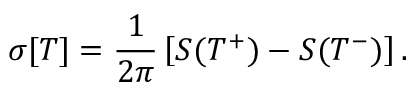<formula> <loc_0><loc_0><loc_500><loc_500>\sigma [ T ] = { \frac { 1 } { 2 \pi } } \left [ S ( T ^ { + } ) - S ( T ^ { - } ) \right ] .</formula> 